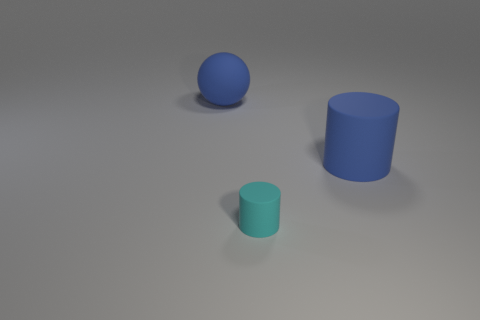Do the blue matte thing to the right of the ball and the sphere have the same size?
Your response must be concise. Yes. What number of other things are there of the same size as the ball?
Keep it short and to the point. 1. The tiny cylinder has what color?
Give a very brief answer. Cyan. What is the material of the big thing on the right side of the sphere?
Your answer should be compact. Rubber. Is the number of objects that are in front of the large blue cylinder the same as the number of matte spheres?
Ensure brevity in your answer.  Yes. Are there any other things that are the same color as the big matte ball?
Make the answer very short. Yes. The matte thing that is behind the cyan matte object and to the left of the blue cylinder has what shape?
Offer a very short reply. Sphere. Is the number of large blue cylinders that are on the right side of the large cylinder the same as the number of big balls that are left of the blue sphere?
Make the answer very short. Yes. How many cylinders are tiny cyan things or matte objects?
Provide a short and direct response. 2. How many balls are made of the same material as the blue cylinder?
Make the answer very short. 1. 